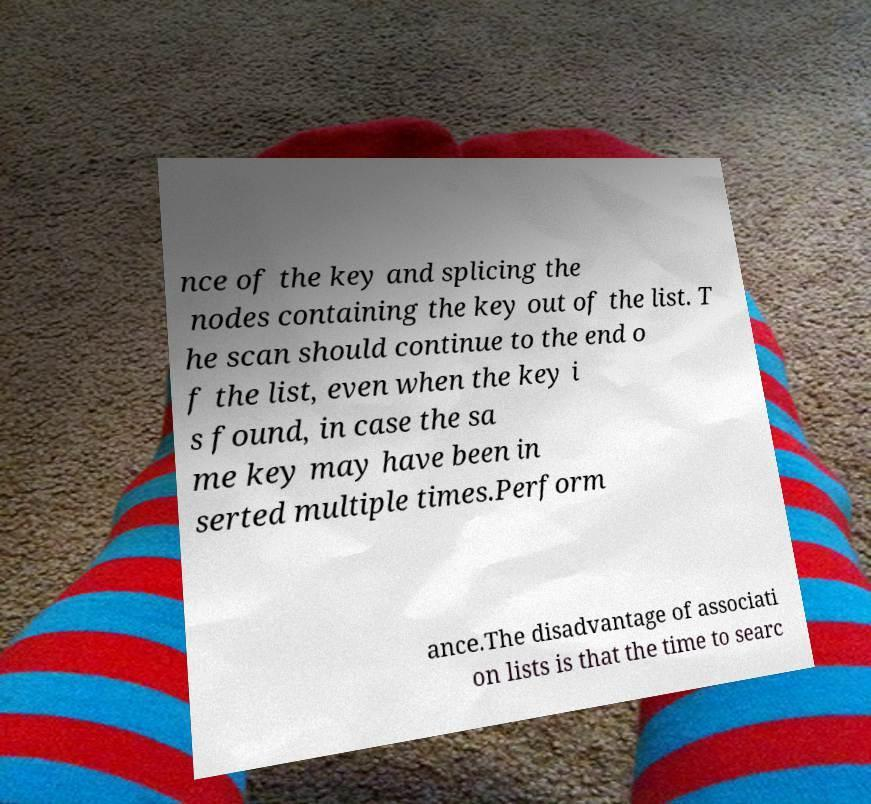Please identify and transcribe the text found in this image. nce of the key and splicing the nodes containing the key out of the list. T he scan should continue to the end o f the list, even when the key i s found, in case the sa me key may have been in serted multiple times.Perform ance.The disadvantage of associati on lists is that the time to searc 